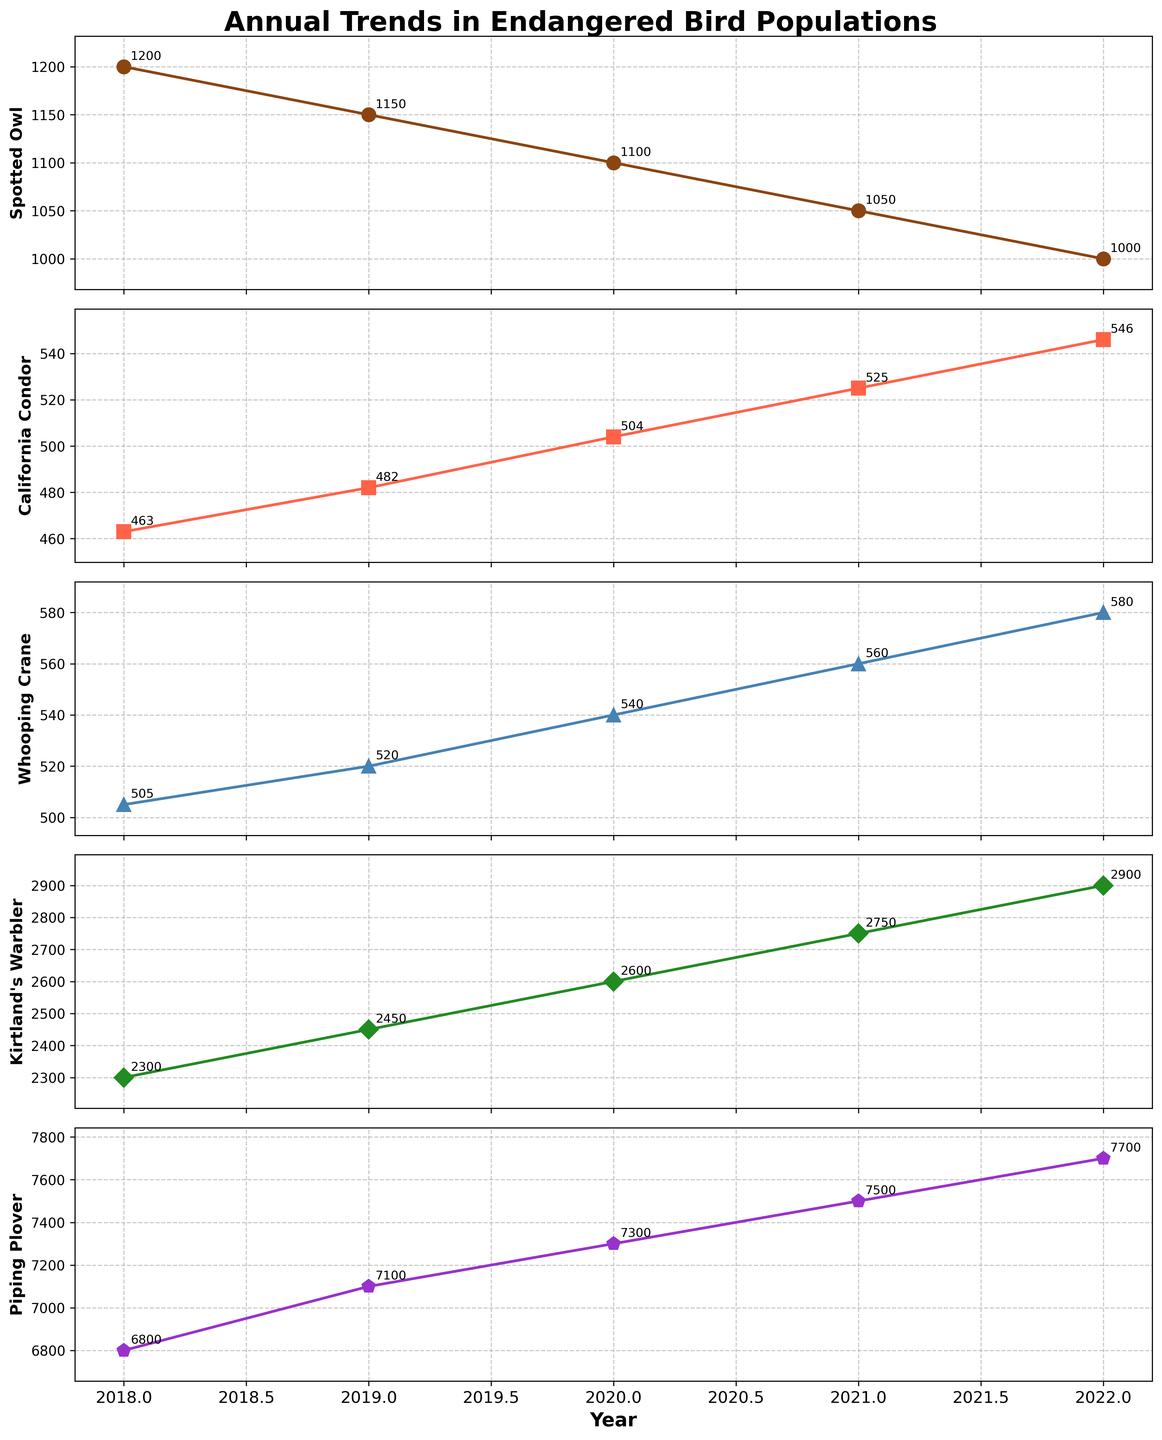What is the title of the plot? The title of the plot is often found at the top of the figure and serves as a brief description of the overall content. It usually gives a quick idea of what the plot is about.
Answer: Annual Trends in Endangered Bird Populations How many bird species are shown in the subplots? Count the different species listed on the y-axis label of each subplot.
Answer: 5 Which year shows the highest population count for the California Condor? Look at the data points for the California Condor in its subplot and identify the year with the highest count. The label next to the highest marker will help identify the year.
Answer: 2022 By how much did the population of Kirtland's Warbler increase from 2018 to 2019? Subtract the population count of Kirtland's Warbler in 2018 from its population in 2019. This involves finding the values in the corresponding subplot and performing the subtraction.
Answer: 150 Which species has the most consistent decline in population from 2018 to 2022? Examine the trends in each subplot to identify which species shows a steady decrease in population each year. The species with a clear downward trend without any increase would be the answer.
Answer: Spotted Owl What is the average population of the Piping Plover over the years? To find the average, add the population counts of the Piping Plover for all the years shown and divide by the number of years. Sum = (6800+7100+7300+7500+7700) = 36400, divide by 5.
Answer: 7280 Which bird species had a population of 560 in the year 2021? Look at the 2021 data points and identify the subplot where the label for 2021 matches 560.
Answer: Whooping Crane How much did the population of the Spotted Owl decrease from 2020 to 2021? Subtract the population count of the Spotted Owl in 2021 from its population in 2020.
Answer: 50 Between the California Condor and the Whooping Crane, which species showed a greater increase in population from 2018 to 2022? Calculate the increase in population for both species over the period. For the California Condor: Increase = 546 - 463 = 83. For the Whooping Crane: Increase = 580 - 505 = 75.
Answer: California Condor Which year saw the highest population count for the Piping Plover? Look at the data points and labels for the Piping Plover subplot to identify the year with the maximum count.
Answer: 2022 